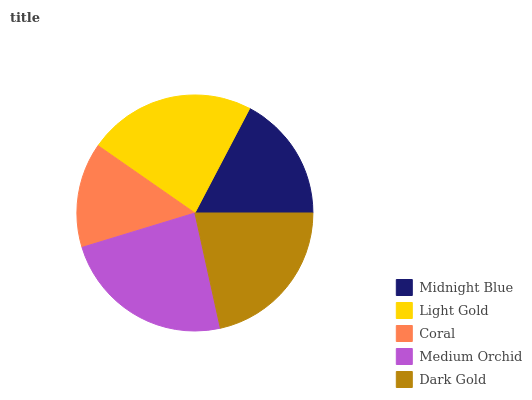Is Coral the minimum?
Answer yes or no. Yes. Is Medium Orchid the maximum?
Answer yes or no. Yes. Is Light Gold the minimum?
Answer yes or no. No. Is Light Gold the maximum?
Answer yes or no. No. Is Light Gold greater than Midnight Blue?
Answer yes or no. Yes. Is Midnight Blue less than Light Gold?
Answer yes or no. Yes. Is Midnight Blue greater than Light Gold?
Answer yes or no. No. Is Light Gold less than Midnight Blue?
Answer yes or no. No. Is Dark Gold the high median?
Answer yes or no. Yes. Is Dark Gold the low median?
Answer yes or no. Yes. Is Medium Orchid the high median?
Answer yes or no. No. Is Midnight Blue the low median?
Answer yes or no. No. 